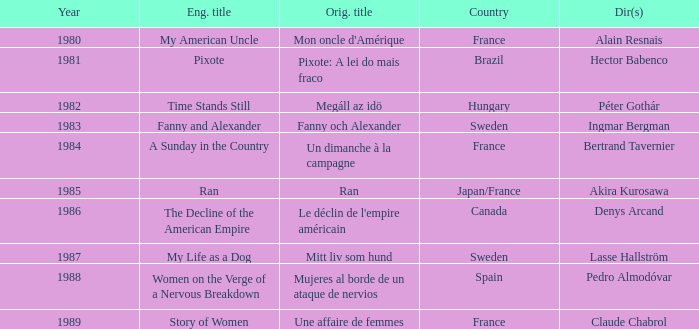What was the original title that was directed by Alain Resnais in France before 1986? Mon oncle d'Amérique. 